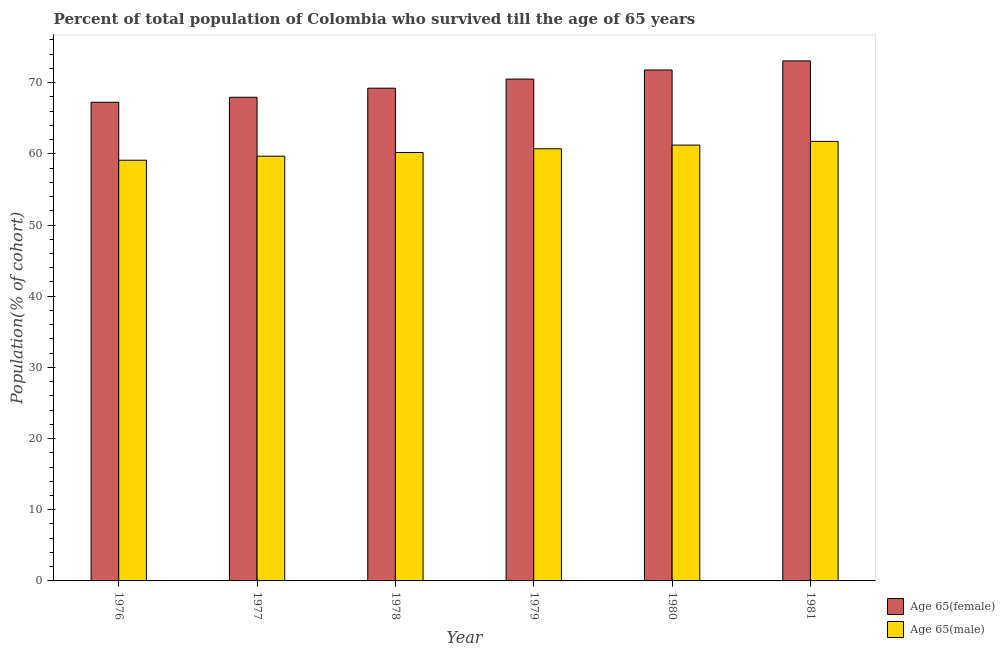How many different coloured bars are there?
Your answer should be very brief. 2. Are the number of bars on each tick of the X-axis equal?
Keep it short and to the point. Yes. How many bars are there on the 5th tick from the left?
Offer a terse response. 2. What is the label of the 1st group of bars from the left?
Offer a very short reply. 1976. In how many cases, is the number of bars for a given year not equal to the number of legend labels?
Make the answer very short. 0. What is the percentage of female population who survived till age of 65 in 1976?
Offer a terse response. 67.25. Across all years, what is the maximum percentage of female population who survived till age of 65?
Your response must be concise. 73.06. Across all years, what is the minimum percentage of male population who survived till age of 65?
Your response must be concise. 59.1. In which year was the percentage of female population who survived till age of 65 maximum?
Your response must be concise. 1981. In which year was the percentage of male population who survived till age of 65 minimum?
Give a very brief answer. 1976. What is the total percentage of male population who survived till age of 65 in the graph?
Ensure brevity in your answer.  362.66. What is the difference between the percentage of male population who survived till age of 65 in 1976 and that in 1978?
Your response must be concise. -1.09. What is the difference between the percentage of male population who survived till age of 65 in 1976 and the percentage of female population who survived till age of 65 in 1979?
Provide a short and direct response. -1.61. What is the average percentage of female population who survived till age of 65 per year?
Make the answer very short. 69.96. In the year 1977, what is the difference between the percentage of female population who survived till age of 65 and percentage of male population who survived till age of 65?
Provide a short and direct response. 0. What is the ratio of the percentage of male population who survived till age of 65 in 1977 to that in 1980?
Offer a very short reply. 0.97. Is the percentage of female population who survived till age of 65 in 1978 less than that in 1979?
Your answer should be compact. Yes. Is the difference between the percentage of female population who survived till age of 65 in 1978 and 1981 greater than the difference between the percentage of male population who survived till age of 65 in 1978 and 1981?
Make the answer very short. No. What is the difference between the highest and the second highest percentage of male population who survived till age of 65?
Offer a terse response. 0.52. What is the difference between the highest and the lowest percentage of male population who survived till age of 65?
Make the answer very short. 2.65. Is the sum of the percentage of male population who survived till age of 65 in 1976 and 1977 greater than the maximum percentage of female population who survived till age of 65 across all years?
Your answer should be compact. Yes. What does the 1st bar from the left in 1976 represents?
Your answer should be compact. Age 65(female). What does the 1st bar from the right in 1978 represents?
Provide a succinct answer. Age 65(male). Are all the bars in the graph horizontal?
Keep it short and to the point. No. How many years are there in the graph?
Your response must be concise. 6. Does the graph contain grids?
Your answer should be compact. No. Where does the legend appear in the graph?
Provide a succinct answer. Bottom right. How are the legend labels stacked?
Offer a terse response. Vertical. What is the title of the graph?
Offer a very short reply. Percent of total population of Colombia who survived till the age of 65 years. What is the label or title of the X-axis?
Make the answer very short. Year. What is the label or title of the Y-axis?
Ensure brevity in your answer.  Population(% of cohort). What is the Population(% of cohort) in Age 65(female) in 1976?
Ensure brevity in your answer.  67.25. What is the Population(% of cohort) in Age 65(male) in 1976?
Give a very brief answer. 59.1. What is the Population(% of cohort) in Age 65(female) in 1977?
Offer a terse response. 67.95. What is the Population(% of cohort) of Age 65(male) in 1977?
Your answer should be compact. 59.67. What is the Population(% of cohort) in Age 65(female) in 1978?
Your answer should be very brief. 69.23. What is the Population(% of cohort) of Age 65(male) in 1978?
Offer a very short reply. 60.19. What is the Population(% of cohort) of Age 65(female) in 1979?
Offer a very short reply. 70.5. What is the Population(% of cohort) in Age 65(male) in 1979?
Provide a short and direct response. 60.71. What is the Population(% of cohort) in Age 65(female) in 1980?
Offer a very short reply. 71.78. What is the Population(% of cohort) in Age 65(male) in 1980?
Your response must be concise. 61.23. What is the Population(% of cohort) in Age 65(female) in 1981?
Offer a terse response. 73.06. What is the Population(% of cohort) in Age 65(male) in 1981?
Provide a succinct answer. 61.75. Across all years, what is the maximum Population(% of cohort) in Age 65(female)?
Your response must be concise. 73.06. Across all years, what is the maximum Population(% of cohort) in Age 65(male)?
Offer a very short reply. 61.75. Across all years, what is the minimum Population(% of cohort) of Age 65(female)?
Provide a succinct answer. 67.25. Across all years, what is the minimum Population(% of cohort) in Age 65(male)?
Your response must be concise. 59.1. What is the total Population(% of cohort) of Age 65(female) in the graph?
Provide a short and direct response. 419.77. What is the total Population(% of cohort) of Age 65(male) in the graph?
Give a very brief answer. 362.66. What is the difference between the Population(% of cohort) of Age 65(female) in 1976 and that in 1977?
Make the answer very short. -0.7. What is the difference between the Population(% of cohort) in Age 65(male) in 1976 and that in 1977?
Give a very brief answer. -0.57. What is the difference between the Population(% of cohort) in Age 65(female) in 1976 and that in 1978?
Ensure brevity in your answer.  -1.98. What is the difference between the Population(% of cohort) of Age 65(male) in 1976 and that in 1978?
Ensure brevity in your answer.  -1.09. What is the difference between the Population(% of cohort) in Age 65(female) in 1976 and that in 1979?
Offer a very short reply. -3.26. What is the difference between the Population(% of cohort) in Age 65(male) in 1976 and that in 1979?
Your answer should be very brief. -1.61. What is the difference between the Population(% of cohort) in Age 65(female) in 1976 and that in 1980?
Keep it short and to the point. -4.53. What is the difference between the Population(% of cohort) of Age 65(male) in 1976 and that in 1980?
Provide a succinct answer. -2.13. What is the difference between the Population(% of cohort) of Age 65(female) in 1976 and that in 1981?
Make the answer very short. -5.81. What is the difference between the Population(% of cohort) of Age 65(male) in 1976 and that in 1981?
Your response must be concise. -2.65. What is the difference between the Population(% of cohort) in Age 65(female) in 1977 and that in 1978?
Your answer should be compact. -1.28. What is the difference between the Population(% of cohort) in Age 65(male) in 1977 and that in 1978?
Provide a succinct answer. -0.52. What is the difference between the Population(% of cohort) of Age 65(female) in 1977 and that in 1979?
Keep it short and to the point. -2.56. What is the difference between the Population(% of cohort) in Age 65(male) in 1977 and that in 1979?
Your answer should be very brief. -1.04. What is the difference between the Population(% of cohort) in Age 65(female) in 1977 and that in 1980?
Ensure brevity in your answer.  -3.84. What is the difference between the Population(% of cohort) in Age 65(male) in 1977 and that in 1980?
Your answer should be very brief. -1.56. What is the difference between the Population(% of cohort) of Age 65(female) in 1977 and that in 1981?
Offer a terse response. -5.11. What is the difference between the Population(% of cohort) in Age 65(male) in 1977 and that in 1981?
Your response must be concise. -2.08. What is the difference between the Population(% of cohort) in Age 65(female) in 1978 and that in 1979?
Keep it short and to the point. -1.28. What is the difference between the Population(% of cohort) of Age 65(male) in 1978 and that in 1979?
Make the answer very short. -0.52. What is the difference between the Population(% of cohort) in Age 65(female) in 1978 and that in 1980?
Your answer should be very brief. -2.56. What is the difference between the Population(% of cohort) in Age 65(male) in 1978 and that in 1980?
Keep it short and to the point. -1.04. What is the difference between the Population(% of cohort) in Age 65(female) in 1978 and that in 1981?
Your answer should be compact. -3.84. What is the difference between the Population(% of cohort) in Age 65(male) in 1978 and that in 1981?
Your answer should be compact. -1.56. What is the difference between the Population(% of cohort) in Age 65(female) in 1979 and that in 1980?
Your answer should be compact. -1.28. What is the difference between the Population(% of cohort) of Age 65(male) in 1979 and that in 1980?
Your answer should be compact. -0.52. What is the difference between the Population(% of cohort) in Age 65(female) in 1979 and that in 1981?
Your answer should be compact. -2.56. What is the difference between the Population(% of cohort) of Age 65(male) in 1979 and that in 1981?
Give a very brief answer. -1.04. What is the difference between the Population(% of cohort) in Age 65(female) in 1980 and that in 1981?
Your response must be concise. -1.28. What is the difference between the Population(% of cohort) of Age 65(male) in 1980 and that in 1981?
Your answer should be compact. -0.52. What is the difference between the Population(% of cohort) of Age 65(female) in 1976 and the Population(% of cohort) of Age 65(male) in 1977?
Your answer should be very brief. 7.58. What is the difference between the Population(% of cohort) of Age 65(female) in 1976 and the Population(% of cohort) of Age 65(male) in 1978?
Give a very brief answer. 7.06. What is the difference between the Population(% of cohort) of Age 65(female) in 1976 and the Population(% of cohort) of Age 65(male) in 1979?
Your response must be concise. 6.54. What is the difference between the Population(% of cohort) in Age 65(female) in 1976 and the Population(% of cohort) in Age 65(male) in 1980?
Make the answer very short. 6.02. What is the difference between the Population(% of cohort) of Age 65(female) in 1976 and the Population(% of cohort) of Age 65(male) in 1981?
Offer a terse response. 5.5. What is the difference between the Population(% of cohort) in Age 65(female) in 1977 and the Population(% of cohort) in Age 65(male) in 1978?
Your answer should be compact. 7.76. What is the difference between the Population(% of cohort) in Age 65(female) in 1977 and the Population(% of cohort) in Age 65(male) in 1979?
Provide a short and direct response. 7.24. What is the difference between the Population(% of cohort) of Age 65(female) in 1977 and the Population(% of cohort) of Age 65(male) in 1980?
Offer a very short reply. 6.72. What is the difference between the Population(% of cohort) in Age 65(female) in 1977 and the Population(% of cohort) in Age 65(male) in 1981?
Provide a succinct answer. 6.2. What is the difference between the Population(% of cohort) in Age 65(female) in 1978 and the Population(% of cohort) in Age 65(male) in 1979?
Make the answer very short. 8.51. What is the difference between the Population(% of cohort) of Age 65(female) in 1978 and the Population(% of cohort) of Age 65(male) in 1980?
Keep it short and to the point. 7.99. What is the difference between the Population(% of cohort) of Age 65(female) in 1978 and the Population(% of cohort) of Age 65(male) in 1981?
Offer a terse response. 7.47. What is the difference between the Population(% of cohort) of Age 65(female) in 1979 and the Population(% of cohort) of Age 65(male) in 1980?
Ensure brevity in your answer.  9.27. What is the difference between the Population(% of cohort) in Age 65(female) in 1979 and the Population(% of cohort) in Age 65(male) in 1981?
Provide a succinct answer. 8.75. What is the difference between the Population(% of cohort) of Age 65(female) in 1980 and the Population(% of cohort) of Age 65(male) in 1981?
Keep it short and to the point. 10.03. What is the average Population(% of cohort) in Age 65(female) per year?
Your answer should be compact. 69.96. What is the average Population(% of cohort) of Age 65(male) per year?
Your answer should be compact. 60.44. In the year 1976, what is the difference between the Population(% of cohort) in Age 65(female) and Population(% of cohort) in Age 65(male)?
Offer a very short reply. 8.15. In the year 1977, what is the difference between the Population(% of cohort) in Age 65(female) and Population(% of cohort) in Age 65(male)?
Offer a very short reply. 8.28. In the year 1978, what is the difference between the Population(% of cohort) in Age 65(female) and Population(% of cohort) in Age 65(male)?
Your response must be concise. 9.03. In the year 1979, what is the difference between the Population(% of cohort) in Age 65(female) and Population(% of cohort) in Age 65(male)?
Provide a short and direct response. 9.79. In the year 1980, what is the difference between the Population(% of cohort) in Age 65(female) and Population(% of cohort) in Age 65(male)?
Your answer should be compact. 10.55. In the year 1981, what is the difference between the Population(% of cohort) of Age 65(female) and Population(% of cohort) of Age 65(male)?
Offer a terse response. 11.31. What is the ratio of the Population(% of cohort) of Age 65(female) in 1976 to that in 1977?
Provide a short and direct response. 0.99. What is the ratio of the Population(% of cohort) in Age 65(male) in 1976 to that in 1977?
Your answer should be very brief. 0.99. What is the ratio of the Population(% of cohort) of Age 65(female) in 1976 to that in 1978?
Your response must be concise. 0.97. What is the ratio of the Population(% of cohort) in Age 65(male) in 1976 to that in 1978?
Keep it short and to the point. 0.98. What is the ratio of the Population(% of cohort) of Age 65(female) in 1976 to that in 1979?
Provide a short and direct response. 0.95. What is the ratio of the Population(% of cohort) in Age 65(male) in 1976 to that in 1979?
Provide a succinct answer. 0.97. What is the ratio of the Population(% of cohort) of Age 65(female) in 1976 to that in 1980?
Ensure brevity in your answer.  0.94. What is the ratio of the Population(% of cohort) in Age 65(male) in 1976 to that in 1980?
Make the answer very short. 0.97. What is the ratio of the Population(% of cohort) in Age 65(female) in 1976 to that in 1981?
Offer a terse response. 0.92. What is the ratio of the Population(% of cohort) in Age 65(male) in 1976 to that in 1981?
Offer a terse response. 0.96. What is the ratio of the Population(% of cohort) of Age 65(female) in 1977 to that in 1978?
Your response must be concise. 0.98. What is the ratio of the Population(% of cohort) of Age 65(male) in 1977 to that in 1978?
Give a very brief answer. 0.99. What is the ratio of the Population(% of cohort) of Age 65(female) in 1977 to that in 1979?
Give a very brief answer. 0.96. What is the ratio of the Population(% of cohort) of Age 65(male) in 1977 to that in 1979?
Provide a short and direct response. 0.98. What is the ratio of the Population(% of cohort) in Age 65(female) in 1977 to that in 1980?
Keep it short and to the point. 0.95. What is the ratio of the Population(% of cohort) in Age 65(male) in 1977 to that in 1980?
Offer a very short reply. 0.97. What is the ratio of the Population(% of cohort) in Age 65(male) in 1977 to that in 1981?
Provide a succinct answer. 0.97. What is the ratio of the Population(% of cohort) of Age 65(female) in 1978 to that in 1979?
Keep it short and to the point. 0.98. What is the ratio of the Population(% of cohort) in Age 65(female) in 1978 to that in 1980?
Offer a very short reply. 0.96. What is the ratio of the Population(% of cohort) of Age 65(male) in 1978 to that in 1980?
Your response must be concise. 0.98. What is the ratio of the Population(% of cohort) of Age 65(female) in 1978 to that in 1981?
Offer a terse response. 0.95. What is the ratio of the Population(% of cohort) in Age 65(male) in 1978 to that in 1981?
Keep it short and to the point. 0.97. What is the ratio of the Population(% of cohort) of Age 65(female) in 1979 to that in 1980?
Give a very brief answer. 0.98. What is the ratio of the Population(% of cohort) in Age 65(male) in 1979 to that in 1981?
Keep it short and to the point. 0.98. What is the ratio of the Population(% of cohort) of Age 65(female) in 1980 to that in 1981?
Offer a very short reply. 0.98. What is the ratio of the Population(% of cohort) in Age 65(male) in 1980 to that in 1981?
Your answer should be very brief. 0.99. What is the difference between the highest and the second highest Population(% of cohort) in Age 65(female)?
Ensure brevity in your answer.  1.28. What is the difference between the highest and the second highest Population(% of cohort) in Age 65(male)?
Your answer should be very brief. 0.52. What is the difference between the highest and the lowest Population(% of cohort) of Age 65(female)?
Offer a terse response. 5.81. What is the difference between the highest and the lowest Population(% of cohort) in Age 65(male)?
Offer a terse response. 2.65. 